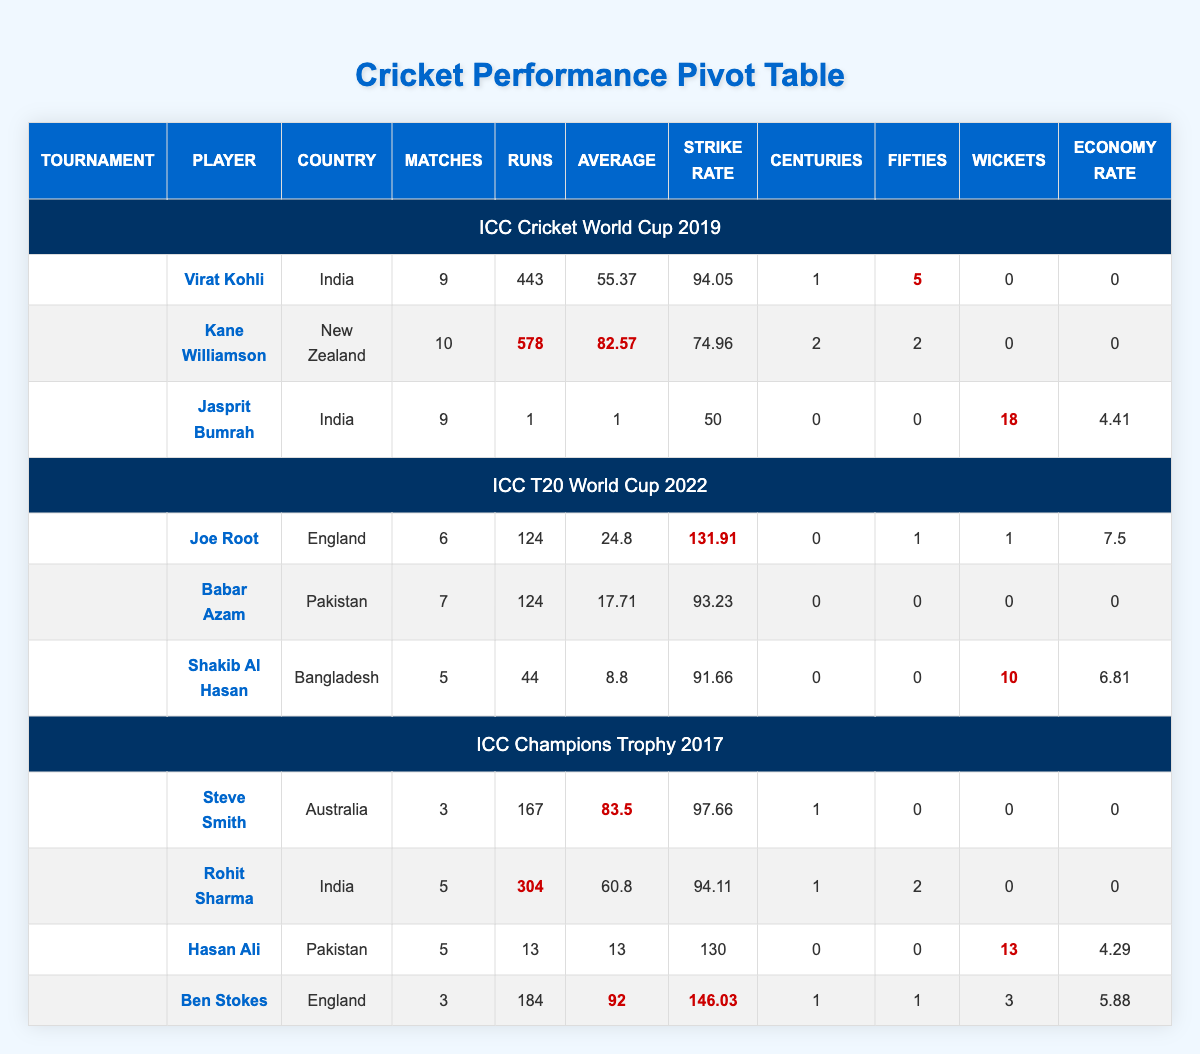What was Kane Williamson's average in the ICC Cricket World Cup 2019? Kane Williamson's average can be found in the ICC Cricket World Cup 2019 section of the table, specifically in the row associated with his name. The average is listed as 82.57.
Answer: 82.57 How many wickets did Jasprit Bumrah take in the ICC Cricket World Cup 2019? The number of wickets taken by Jasprit Bumrah can be found in the ICC Cricket World Cup 2019 section of the table. The table shows that he took 18 wickets.
Answer: 18 Which player had the highest strike rate in the ICC T20 World Cup 2022? To find the highest strike rate in the ICC T20 World Cup 2022 section, we compare the strike rates of each player listed under that tournament. Joe Root had the highest strike rate of 131.91.
Answer: Joe Root Did Rohit Sharma score any centuries in the ICC Champions Trophy 2017? Checking the ICC Champions Trophy 2017 section of the table, we see Rohit Sharma's centuries column. It indicates that he scored 1 century, so the answer is yes.
Answer: Yes What is the total number of runs scored by all players from India in the ICC Cricket World Cup 2019? The players from India in this tournament include Virat Kohli and Jasprit Bumrah. Virat Kohli scored 443 runs and Jasprit Bumrah scored 1 run. Adding these gives 443 + 1 = 444.
Answer: 444 Which tournament had the most wickets taken by a single player, and who was that player? We look at the tournaments and see that in the ICC Cricket World Cup 2019, Jasprit Bumrah took 18 wickets. In the ICC T20 World Cup 2022, Shakib Al Hasan took 10 wickets, and in the ICC Champions Trophy 2017, Hasan Ali took 13 wickets. The player with the most wickets is Jasprit Bumrah in the ICC Cricket World Cup 2019 with 18 wickets.
Answer: ICC Cricket World Cup 2019, Jasprit Bumrah What was the strike rate of Ben Stokes in the ICC Champions Trophy 2017? Ben Stokes's strike rate can be found in the ICC Champions Trophy 2017 section of the table. It shows that his strike rate was 146.03.
Answer: 146.03 Which player's performance had the highest average across all tournaments listed? To find the player with the highest average, we compare average values of all players. Kane Williamson's average in the ICC Cricket World Cup 2019 is 82.57, which is higher than any other player's average in the table. Analyzing the averages shows that Kane Williamson had the highest average.
Answer: Kane Williamson Was Babar Azam able to achieve any fifties in the ICC T20 World Cup 2022? Checking the ICC T20 World Cup 2022 section of the table, we find that Babar Azam's fifties column shows 0, meaning he did not score any fifties.
Answer: No 